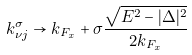Convert formula to latex. <formula><loc_0><loc_0><loc_500><loc_500>k _ { \nu j } ^ { \sigma } \to k _ { F _ { x } } + \sigma \frac { \sqrt { E ^ { 2 } - | \Delta | ^ { 2 } } } { 2 k _ { F _ { x } } }</formula> 